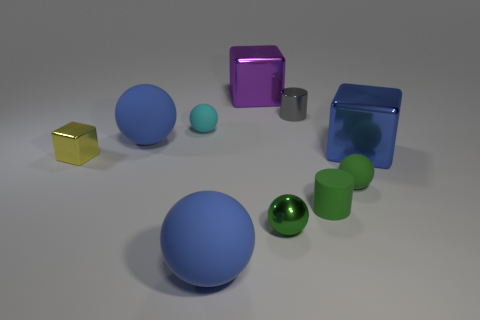Subtract all cyan balls. How many balls are left? 4 Subtract all green rubber spheres. How many spheres are left? 4 Subtract all gray spheres. Subtract all cyan blocks. How many spheres are left? 5 Subtract all cylinders. How many objects are left? 8 Add 4 small yellow metallic objects. How many small yellow metallic objects are left? 5 Add 6 yellow rubber cylinders. How many yellow rubber cylinders exist? 6 Subtract 1 cyan balls. How many objects are left? 9 Subtract all purple metallic objects. Subtract all yellow metallic blocks. How many objects are left? 8 